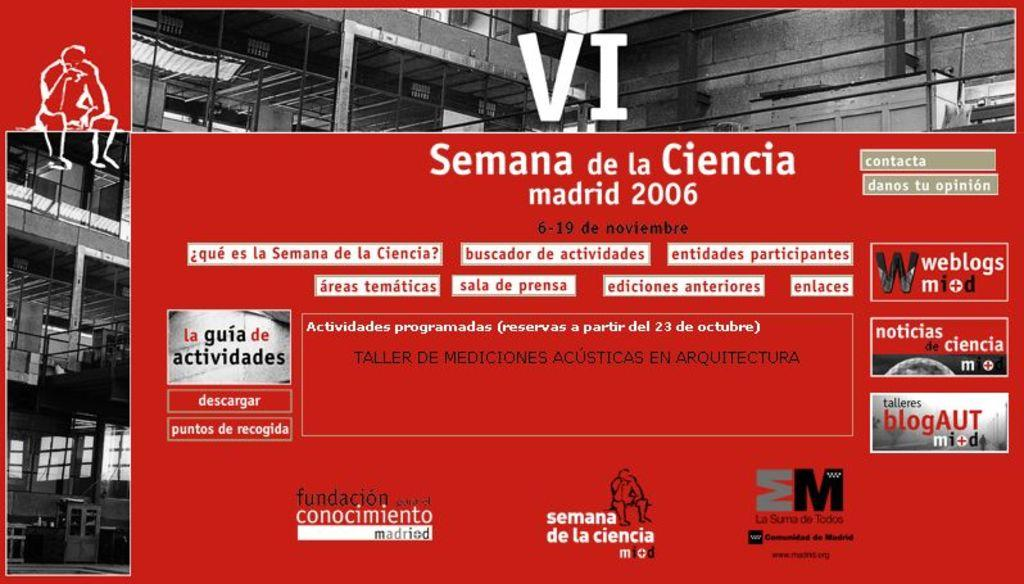<image>
Render a clear and concise summary of the photo. A sign with VI on the front has the location of Madrid in 2006. 